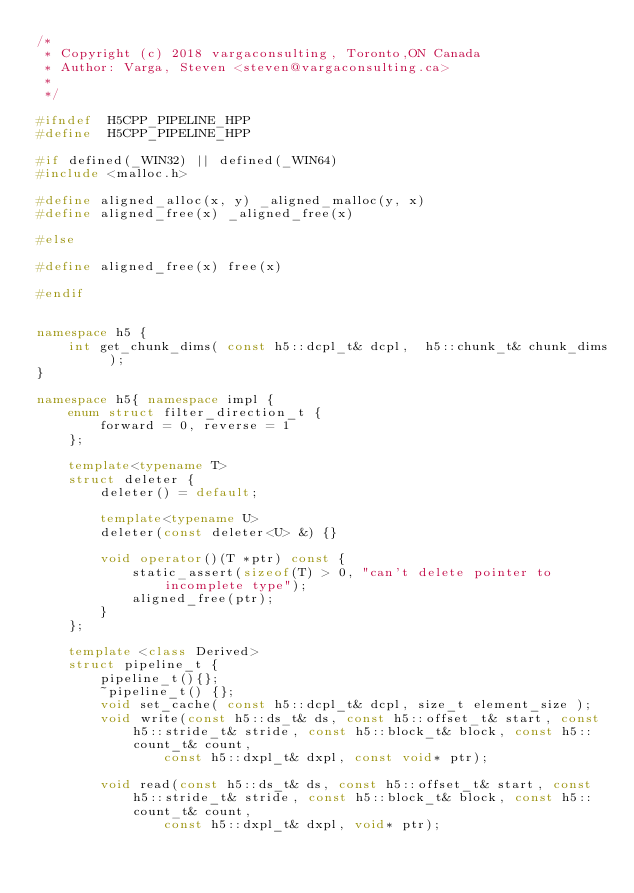Convert code to text. <code><loc_0><loc_0><loc_500><loc_500><_C++_>/*
 * Copyright (c) 2018 vargaconsulting, Toronto,ON Canada
 * Author: Varga, Steven <steven@vargaconsulting.ca>
 *
 */

#ifndef  H5CPP_PIPELINE_HPP
#define  H5CPP_PIPELINE_HPP

#if defined(_WIN32) || defined(_WIN64)
#include <malloc.h>

#define aligned_alloc(x, y) _aligned_malloc(y, x)
#define aligned_free(x) _aligned_free(x)

#else

#define aligned_free(x) free(x)

#endif


namespace h5 {
	int get_chunk_dims( const h5::dcpl_t& dcpl,  h5::chunk_t& chunk_dims );
}

namespace h5{ namespace impl {
	enum struct filter_direction_t {
		forward = 0, reverse = 1
	};

	template<typename T>
	struct deleter {
        deleter() = default;

		template<typename U>
        deleter(const deleter<U> &) {}

		void operator()(T *ptr) const { 
			static_assert(sizeof(T) > 0, "can't delete pointer to incomplete type");
            aligned_free(ptr);
		}
	};

	template <class Derived>
	struct pipeline_t {
		pipeline_t(){};
        ~pipeline_t() {};
		void set_cache( const h5::dcpl_t& dcpl, size_t element_size );
		void write(const h5::ds_t& ds, const h5::offset_t& start, const h5::stride_t& stride, const h5::block_t& block, const h5::count_t& count,
				const h5::dxpl_t& dxpl, const void* ptr);

		void read(const h5::ds_t& ds, const h5::offset_t& start, const h5::stride_t& stride, const h5::block_t& block, const h5::count_t& count,
				const h5::dxpl_t& dxpl, void* ptr);
</code> 